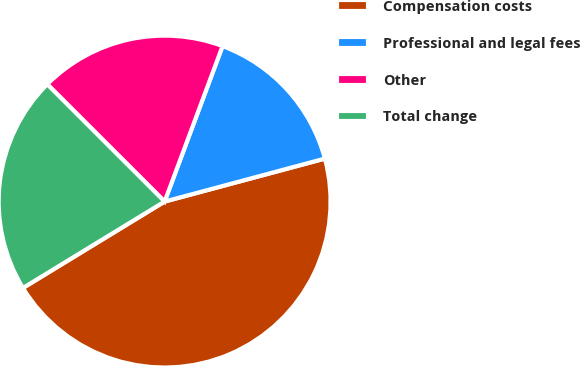Convert chart. <chart><loc_0><loc_0><loc_500><loc_500><pie_chart><fcel>Compensation costs<fcel>Professional and legal fees<fcel>Other<fcel>Total change<nl><fcel>45.45%<fcel>15.15%<fcel>18.18%<fcel>21.21%<nl></chart> 